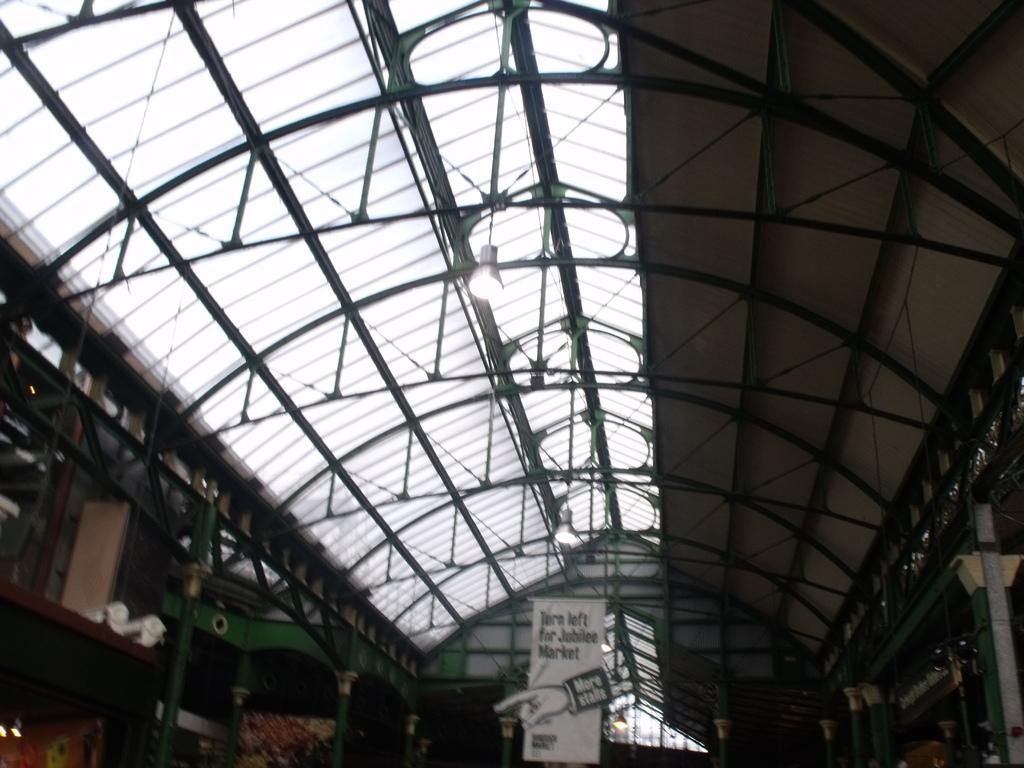Can you describe this image briefly? This picture seems to be clicked inside the hall. In the foreground we can see the text and some picture on the banner which is hanging on the roof and we can see the lights hanging on the roof and we can see the metal rods and the pillars and some other items. 